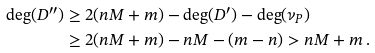<formula> <loc_0><loc_0><loc_500><loc_500>\deg ( D ^ { \prime \prime } ) & \geq 2 ( n M + m ) - \deg ( D ^ { \prime } ) - \deg ( \nu _ { P } ) \\ & \geq 2 ( n M + m ) - n M - ( m - n ) > n M + m \, .</formula> 